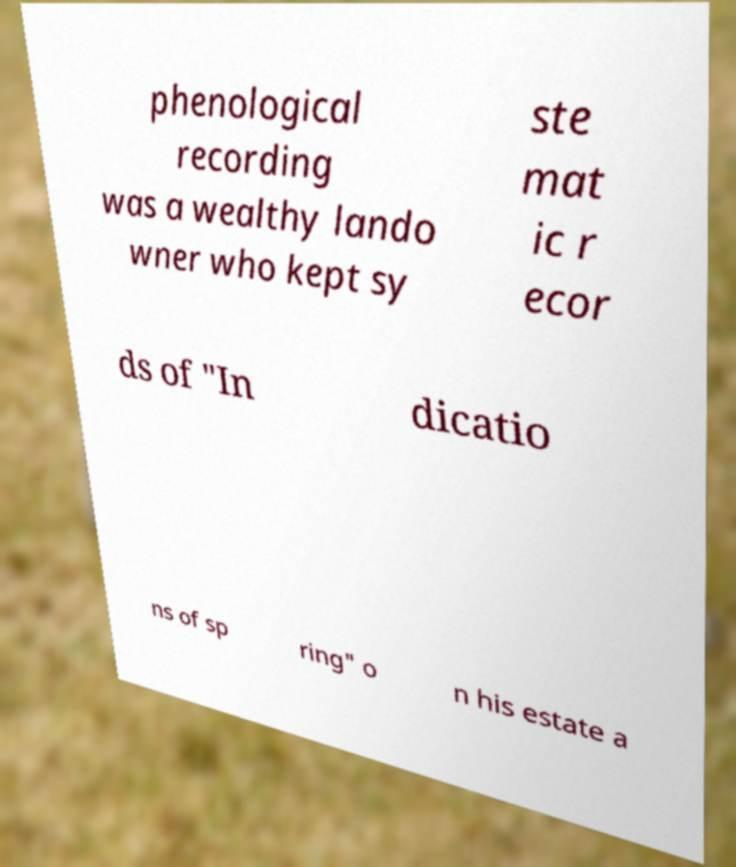Can you accurately transcribe the text from the provided image for me? phenological recording was a wealthy lando wner who kept sy ste mat ic r ecor ds of "In dicatio ns of sp ring" o n his estate a 